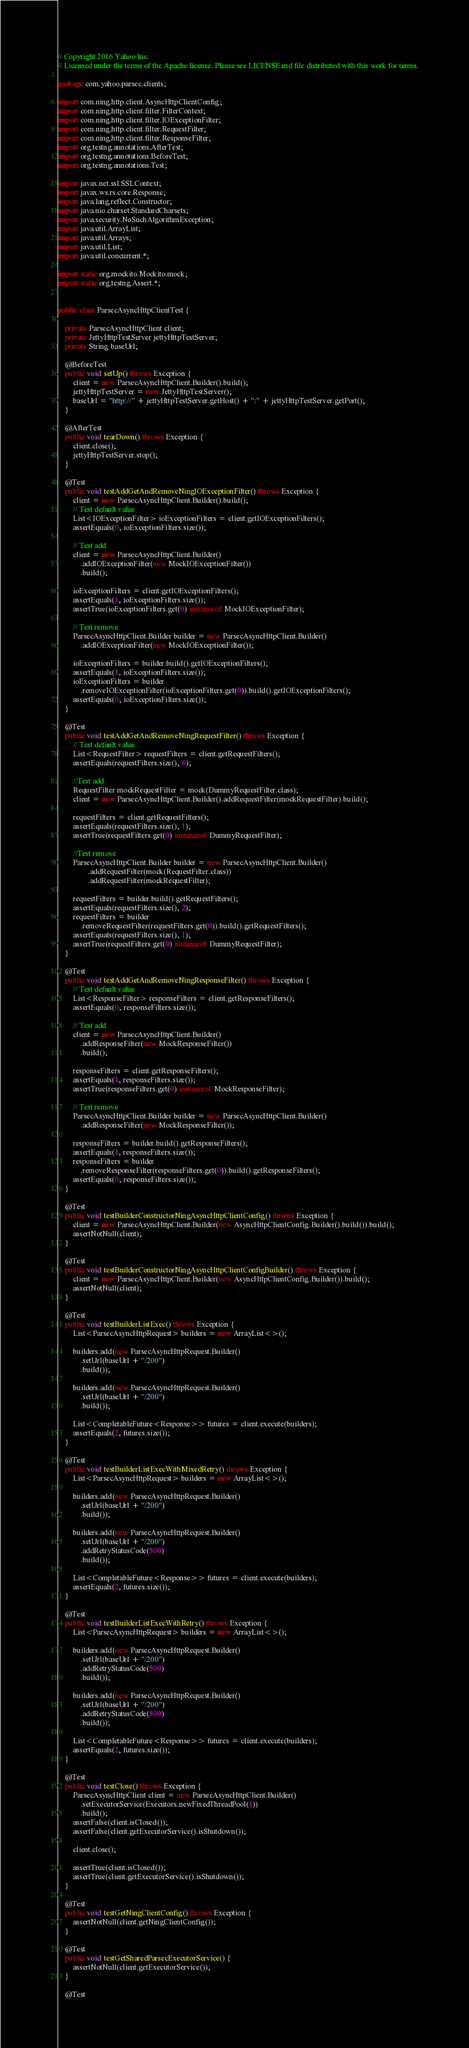Convert code to text. <code><loc_0><loc_0><loc_500><loc_500><_Java_>// Copyright 2016 Yahoo Inc.
// Licensed under the terms of the Apache license. Please see LICENSE.md file distributed with this work for terms.

package com.yahoo.parsec.clients;

import com.ning.http.client.AsyncHttpClientConfig;
import com.ning.http.client.filter.FilterContext;
import com.ning.http.client.filter.IOExceptionFilter;
import com.ning.http.client.filter.RequestFilter;
import com.ning.http.client.filter.ResponseFilter;
import org.testng.annotations.AfterTest;
import org.testng.annotations.BeforeTest;
import org.testng.annotations.Test;

import javax.net.ssl.SSLContext;
import javax.ws.rs.core.Response;
import java.lang.reflect.Constructor;
import java.nio.charset.StandardCharsets;
import java.security.NoSuchAlgorithmException;
import java.util.ArrayList;
import java.util.Arrays;
import java.util.List;
import java.util.concurrent.*;

import static org.mockito.Mockito.mock;
import static org.testng.Assert.*;


public class ParsecAsyncHttpClientTest {

    private ParsecAsyncHttpClient client;
    private JettyHttpTestServer jettyHttpTestServer;
    private String baseUrl;

    @BeforeTest
    public void setUp() throws Exception {
        client = new ParsecAsyncHttpClient.Builder().build();
        jettyHttpTestServer = new JettyHttpTestServer();
        baseUrl = "http://" + jettyHttpTestServer.getHost() + ":" + jettyHttpTestServer.getPort();
    }

    @AfterTest
    public void tearDown() throws Exception {
        client.close();
        jettyHttpTestServer.stop();
    }

    @Test
    public void testAddGetAndRemoveNingIOExceptionFilter() throws Exception {
        client = new ParsecAsyncHttpClient.Builder().build();
        // Test default value
        List<IOExceptionFilter> ioExceptionFilters = client.getIOExceptionFilters();
        assertEquals(0, ioExceptionFilters.size());

        // Test add
        client = new ParsecAsyncHttpClient.Builder()
            .addIOExceptionFilter(new MockIOExceptionFilter())
            .build();

        ioExceptionFilters = client.getIOExceptionFilters();
        assertEquals(1, ioExceptionFilters.size());
        assertTrue(ioExceptionFilters.get(0) instanceof MockIOExceptionFilter);

        // Test remove
        ParsecAsyncHttpClient.Builder builder = new ParsecAsyncHttpClient.Builder()
            .addIOExceptionFilter(new MockIOExceptionFilter());

        ioExceptionFilters = builder.build().getIOExceptionFilters();
        assertEquals(1, ioExceptionFilters.size());
        ioExceptionFilters = builder
            .removeIOExceptionFilter(ioExceptionFilters.get(0)).build().getIOExceptionFilters();
        assertEquals(0, ioExceptionFilters.size());
    }

    @Test
    public void testAddGetAndRemoveNingRequestFilter() throws Exception {
        // Test default value
        List<RequestFilter> requestFilters = client.getRequestFilters();
        assertEquals(requestFilters.size(), 0);

        //Test add
        RequestFilter mockRequestFilter = mock(DummyRequestFilter.class);
        client = new ParsecAsyncHttpClient.Builder().addRequestFilter(mockRequestFilter).build();

        requestFilters = client.getRequestFilters();
        assertEquals(requestFilters.size(), 1);
        assertTrue(requestFilters.get(0) instanceof DummyRequestFilter);

        //Test remove
        ParsecAsyncHttpClient.Builder builder = new ParsecAsyncHttpClient.Builder()
                .addRequestFilter(mock(RequestFilter.class))
                .addRequestFilter(mockRequestFilter);

        requestFilters = builder.build().getRequestFilters();
        assertEquals(requestFilters.size(), 2);
        requestFilters = builder
            .removeRequestFilter(requestFilters.get(0)).build().getRequestFilters();
        assertEquals(requestFilters.size(), 1);
        assertTrue(requestFilters.get(0) instanceof DummyRequestFilter);
    }

    @Test
    public void testAddGetAndRemoveNingResponseFilter() throws Exception {
        // Test default value
        List<ResponseFilter> responseFilters = client.getResponseFilters();
        assertEquals(0, responseFilters.size());

        // Test add
        client = new ParsecAsyncHttpClient.Builder()
            .addResponseFilter(new MockResponseFilter())
            .build();

        responseFilters = client.getResponseFilters();
        assertEquals(1, responseFilters.size());
        assertTrue(responseFilters.get(0) instanceof MockResponseFilter);

        // Test remove
        ParsecAsyncHttpClient.Builder builder = new ParsecAsyncHttpClient.Builder()
            .addResponseFilter(new MockResponseFilter());

        responseFilters = builder.build().getResponseFilters();
        assertEquals(1, responseFilters.size());
        responseFilters = builder
            .removeResponseFilter(responseFilters.get(0)).build().getResponseFilters();
        assertEquals(0, responseFilters.size());
    }

    @Test
    public void testBuilderConstructorNingAsyncHttpClientConfig() throws Exception {
        client = new ParsecAsyncHttpClient.Builder(new AsyncHttpClientConfig.Builder().build()).build();
        assertNotNull(client);
    }

    @Test
    public void testBuilderConstructorNingAsyncHttpClientConfigBuilder() throws Exception {
        client = new ParsecAsyncHttpClient.Builder(new AsyncHttpClientConfig.Builder()).build();
        assertNotNull(client);
    }

    @Test
    public void testBuilderListExec() throws Exception {
        List<ParsecAsyncHttpRequest> builders = new ArrayList<>();

        builders.add(new ParsecAsyncHttpRequest.Builder()
            .setUrl(baseUrl + "/200")
            .build());

        builders.add(new ParsecAsyncHttpRequest.Builder()
            .setUrl(baseUrl + "/200")
            .build());

        List<CompletableFuture<Response>> futures = client.execute(builders);
        assertEquals(2, futures.size());
    }

    @Test
    public void testBuilderListExecWithMixedRetry() throws Exception {
        List<ParsecAsyncHttpRequest> builders = new ArrayList<>();

        builders.add(new ParsecAsyncHttpRequest.Builder()
            .setUrl(baseUrl + "/200")
            .build());

        builders.add(new ParsecAsyncHttpRequest.Builder()
            .setUrl(baseUrl + "/200")
            .addRetryStatusCode(500)
            .build());

        List<CompletableFuture<Response>> futures = client.execute(builders);
        assertEquals(2, futures.size());
    }

    @Test
    public void testBuilderListExecWithRetry() throws Exception {
        List<ParsecAsyncHttpRequest> builders = new ArrayList<>();

        builders.add(new ParsecAsyncHttpRequest.Builder()
            .setUrl(baseUrl + "/200")
            .addRetryStatusCode(500)
            .build());

        builders.add(new ParsecAsyncHttpRequest.Builder()
            .setUrl(baseUrl + "/200")
            .addRetryStatusCode(500)
            .build());

        List<CompletableFuture<Response>> futures = client.execute(builders);
        assertEquals(2, futures.size());
    }

    @Test
    public void testClose() throws Exception {
        ParsecAsyncHttpClient client = new ParsecAsyncHttpClient.Builder()
            .setExecutorService(Executors.newFixedThreadPool(1))
            .build();
        assertFalse(client.isClosed());
        assertFalse(client.getExecutorService().isShutdown());

        client.close();

        assertTrue(client.isClosed());
        assertTrue(client.getExecutorService().isShutdown());
    }

    @Test
    public void testGetNingClientConfig() throws Exception {
        assertNotNull(client.getNingClientConfig());
    }

    @Test
    public void testGetSharedParsecExecutorService() {
        assertNotNull(client.getExecutorService());
    }

    @Test</code> 